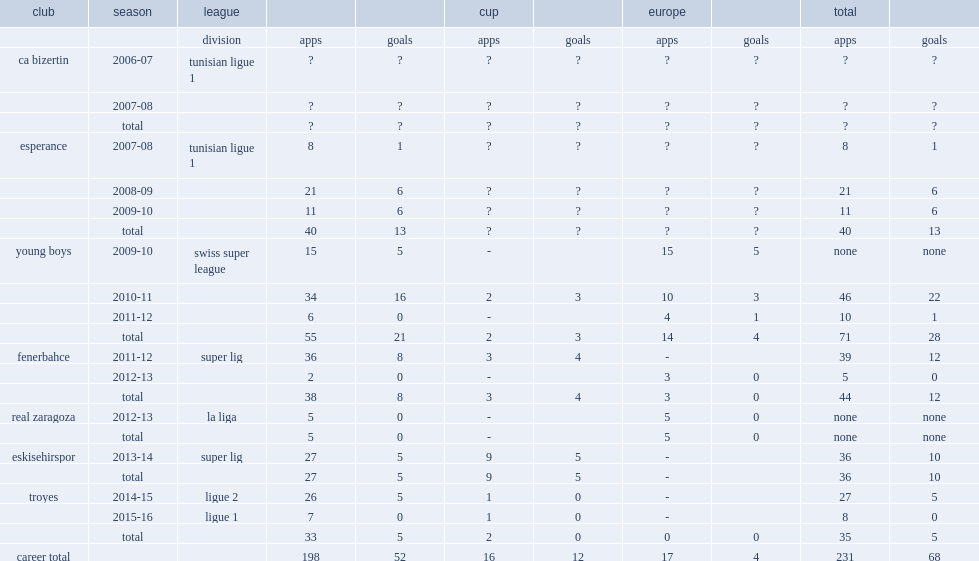How many league goals did henri bienvenu score for esperance in 2008-09? 6.0. 